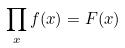<formula> <loc_0><loc_0><loc_500><loc_500>\prod _ { x } f ( x ) = F ( x )</formula> 